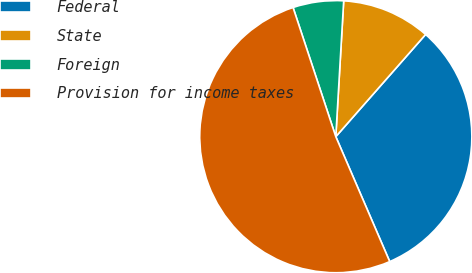Convert chart. <chart><loc_0><loc_0><loc_500><loc_500><pie_chart><fcel>Federal<fcel>State<fcel>Foreign<fcel>Provision for income taxes<nl><fcel>32.04%<fcel>10.55%<fcel>6.01%<fcel>51.4%<nl></chart> 